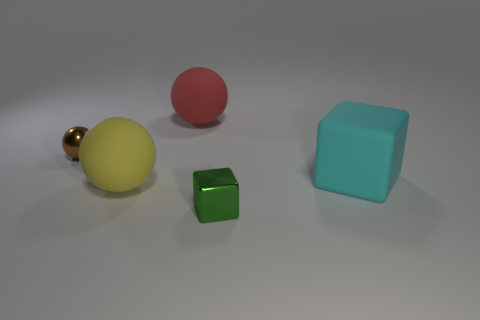What number of things are either matte objects that are behind the brown shiny sphere or gray rubber balls?
Your answer should be compact. 1. Are there an equal number of blue matte cylinders and yellow balls?
Your answer should be compact. No. What is the shape of the green thing that is made of the same material as the small brown object?
Your answer should be very brief. Cube. There is a big red thing; what shape is it?
Keep it short and to the point. Sphere. What is the color of the object that is left of the tiny cube and to the right of the yellow sphere?
Offer a terse response. Red. What shape is the red object that is the same size as the yellow thing?
Provide a short and direct response. Sphere. Is there a big brown thing that has the same shape as the large yellow matte object?
Give a very brief answer. No. Are the tiny brown thing and the large object right of the large red ball made of the same material?
Offer a very short reply. No. What color is the big sphere behind the large ball that is in front of the big thing that is right of the green metallic block?
Make the answer very short. Red. There is another thing that is the same size as the brown thing; what material is it?
Your response must be concise. Metal. 